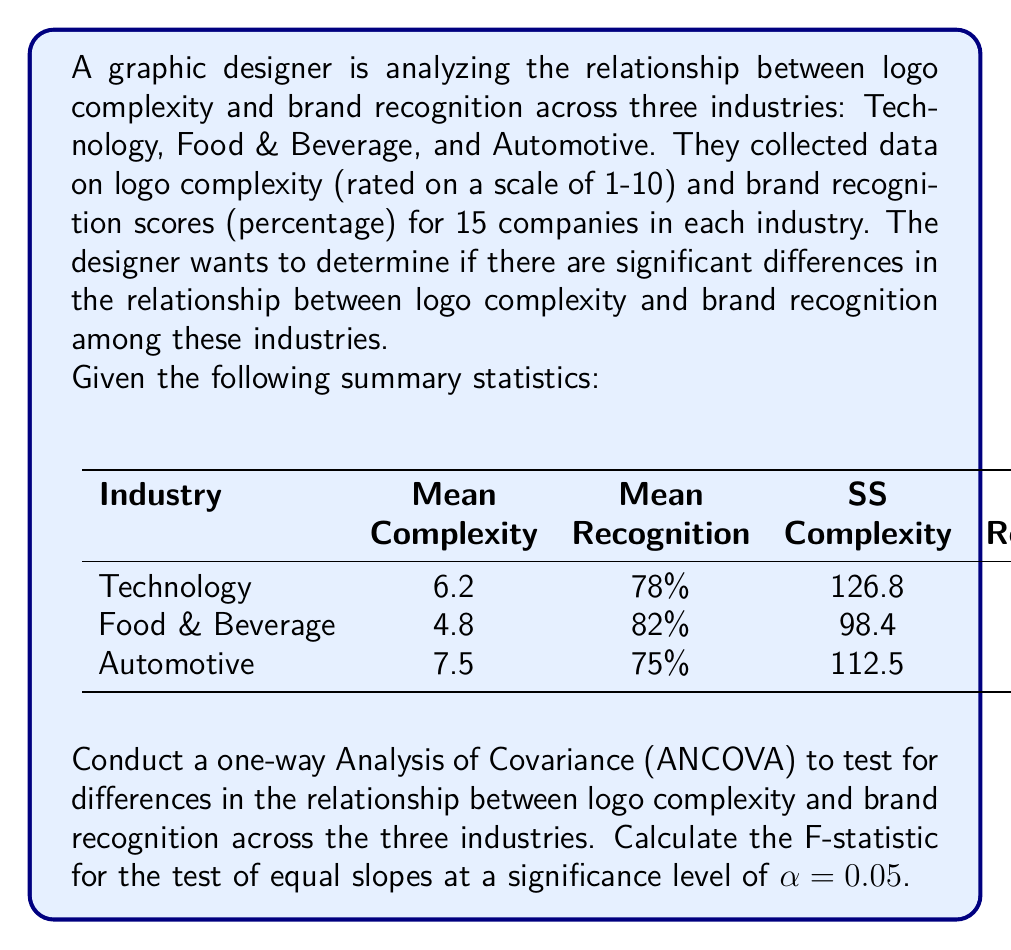Teach me how to tackle this problem. To conduct a one-way ANCOVA and test for equal slopes, we'll follow these steps:

1. Calculate the pooled within-group regression coefficient (b_pooled):

$$b_{pooled} = \frac{\sum SS_{Cross Products}}{\sum SS_{Complexity}} = \frac{495 + 402 + 540}{126.8 + 98.4 + 112.5} = \frac{1437}{337.7} = 4.2553$$

2. Calculate the adjusted sums of squares for recognition (SS_adj):

$$SS_{adj} = \sum SS_{Recognition} - b_{pooled}^2 \sum SS_{Complexity}$$
$$SS_{adj} = (1890 + 1640 + 2250) - 4.2553^2 * 337.7 = 5780 - 6115.8 = -335.8$$

3. Calculate the adjusted mean square for recognition (MS_adj):

$$MS_{adj} = \frac{SS_{adj}}{df_{adj}} = \frac{-335.8}{42} = -7.9952$$

Where df_adj = N - k - 1 = 45 - 3 - 1 = 41 (N is total sample size, k is number of groups)

4. Calculate the sum of squares for equal slopes (SS_slopes):

$$SS_{slopes} = \sum SS_{Recognition} - b_{pooled} \sum SS_{Cross Products}$$
$$SS_{slopes} = 5780 - 4.2553 * 1437 = 5780 - 6114.3651 = -334.3651$$

5. Calculate the mean square for equal slopes (MS_slopes):

$$MS_{slopes} = \frac{SS_{slopes}}{df_{slopes}} = \frac{-334.3651}{2} = -167.1826$$

Where df_slopes = k - 1 = 3 - 1 = 2

6. Calculate the F-statistic:

$$F = \frac{MS_{slopes}}{MS_{adj}} = \frac{-167.1826}{-7.9952} = 20.9103$$

7. Determine the critical F-value:

At α = 0.05, with df_numerator = 2 and df_denominator = 41, the critical F-value is approximately 3.23.

Since the calculated F-statistic (20.9103) is greater than the critical F-value (3.23), we reject the null hypothesis of equal slopes.
Answer: F(2,41) = 20.9103, p < 0.05 